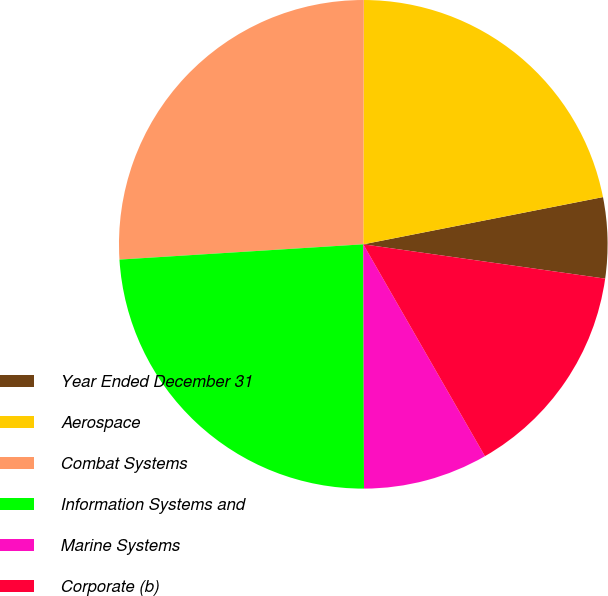Convert chart. <chart><loc_0><loc_0><loc_500><loc_500><pie_chart><fcel>Year Ended December 31<fcel>Aerospace<fcel>Combat Systems<fcel>Information Systems and<fcel>Marine Systems<fcel>Corporate (b)<nl><fcel>5.34%<fcel>21.87%<fcel>26.03%<fcel>24.05%<fcel>8.25%<fcel>14.46%<nl></chart> 